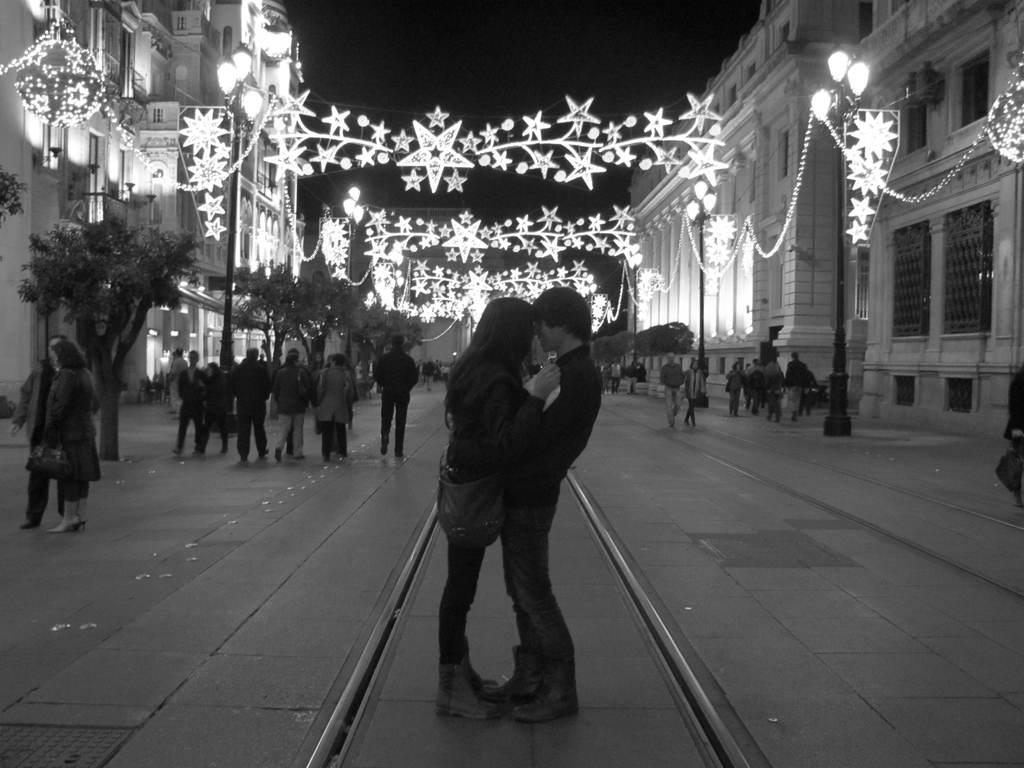How many people are in the image? There is a group of people in the image, but the exact number is not specified. What are some of the people in the image doing? Some people are standing, and some are walking. What can be seen in the background of the image? There are poles, lights, trees, and buildings in the background of the image. What type of wristwatch is the person wearing in the image? There is no wristwatch visible in the image. What scientific discovery is being celebrated in the image? There is no indication of a scientific discovery being celebrated in the image. 